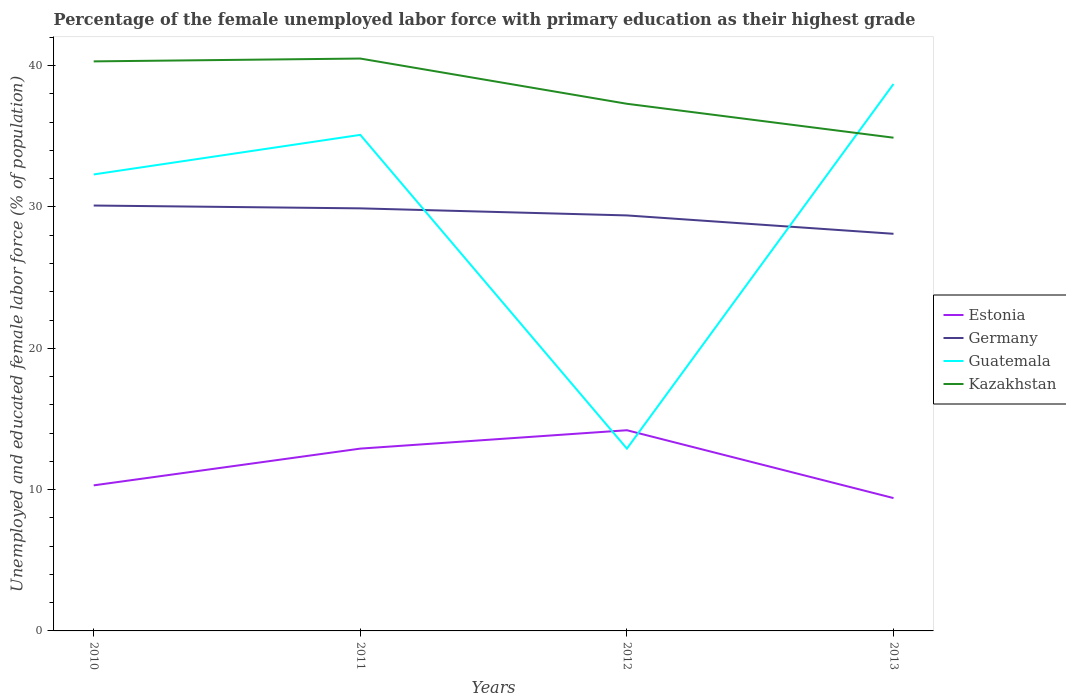How many different coloured lines are there?
Make the answer very short. 4. Is the number of lines equal to the number of legend labels?
Your answer should be compact. Yes. Across all years, what is the maximum percentage of the unemployed female labor force with primary education in Germany?
Provide a short and direct response. 28.1. What is the total percentage of the unemployed female labor force with primary education in Guatemala in the graph?
Your answer should be compact. -3.6. What is the difference between the highest and the second highest percentage of the unemployed female labor force with primary education in Estonia?
Give a very brief answer. 4.8. What is the difference between the highest and the lowest percentage of the unemployed female labor force with primary education in Guatemala?
Ensure brevity in your answer.  3. Is the percentage of the unemployed female labor force with primary education in Kazakhstan strictly greater than the percentage of the unemployed female labor force with primary education in Guatemala over the years?
Provide a succinct answer. No. How many lines are there?
Your response must be concise. 4. How many years are there in the graph?
Give a very brief answer. 4. Are the values on the major ticks of Y-axis written in scientific E-notation?
Keep it short and to the point. No. How many legend labels are there?
Your answer should be very brief. 4. How are the legend labels stacked?
Your answer should be compact. Vertical. What is the title of the graph?
Offer a very short reply. Percentage of the female unemployed labor force with primary education as their highest grade. Does "Belarus" appear as one of the legend labels in the graph?
Give a very brief answer. No. What is the label or title of the X-axis?
Make the answer very short. Years. What is the label or title of the Y-axis?
Your answer should be very brief. Unemployed and educated female labor force (% of population). What is the Unemployed and educated female labor force (% of population) of Estonia in 2010?
Make the answer very short. 10.3. What is the Unemployed and educated female labor force (% of population) in Germany in 2010?
Offer a very short reply. 30.1. What is the Unemployed and educated female labor force (% of population) in Guatemala in 2010?
Keep it short and to the point. 32.3. What is the Unemployed and educated female labor force (% of population) of Kazakhstan in 2010?
Keep it short and to the point. 40.3. What is the Unemployed and educated female labor force (% of population) in Estonia in 2011?
Provide a succinct answer. 12.9. What is the Unemployed and educated female labor force (% of population) in Germany in 2011?
Keep it short and to the point. 29.9. What is the Unemployed and educated female labor force (% of population) in Guatemala in 2011?
Offer a very short reply. 35.1. What is the Unemployed and educated female labor force (% of population) in Kazakhstan in 2011?
Make the answer very short. 40.5. What is the Unemployed and educated female labor force (% of population) in Estonia in 2012?
Make the answer very short. 14.2. What is the Unemployed and educated female labor force (% of population) of Germany in 2012?
Provide a succinct answer. 29.4. What is the Unemployed and educated female labor force (% of population) of Guatemala in 2012?
Provide a short and direct response. 12.9. What is the Unemployed and educated female labor force (% of population) in Kazakhstan in 2012?
Your response must be concise. 37.3. What is the Unemployed and educated female labor force (% of population) in Estonia in 2013?
Make the answer very short. 9.4. What is the Unemployed and educated female labor force (% of population) of Germany in 2013?
Offer a terse response. 28.1. What is the Unemployed and educated female labor force (% of population) of Guatemala in 2013?
Offer a terse response. 38.7. What is the Unemployed and educated female labor force (% of population) of Kazakhstan in 2013?
Provide a short and direct response. 34.9. Across all years, what is the maximum Unemployed and educated female labor force (% of population) of Estonia?
Offer a terse response. 14.2. Across all years, what is the maximum Unemployed and educated female labor force (% of population) in Germany?
Ensure brevity in your answer.  30.1. Across all years, what is the maximum Unemployed and educated female labor force (% of population) in Guatemala?
Your response must be concise. 38.7. Across all years, what is the maximum Unemployed and educated female labor force (% of population) of Kazakhstan?
Keep it short and to the point. 40.5. Across all years, what is the minimum Unemployed and educated female labor force (% of population) of Estonia?
Provide a succinct answer. 9.4. Across all years, what is the minimum Unemployed and educated female labor force (% of population) of Germany?
Offer a very short reply. 28.1. Across all years, what is the minimum Unemployed and educated female labor force (% of population) in Guatemala?
Offer a terse response. 12.9. Across all years, what is the minimum Unemployed and educated female labor force (% of population) in Kazakhstan?
Provide a succinct answer. 34.9. What is the total Unemployed and educated female labor force (% of population) of Estonia in the graph?
Offer a terse response. 46.8. What is the total Unemployed and educated female labor force (% of population) in Germany in the graph?
Your response must be concise. 117.5. What is the total Unemployed and educated female labor force (% of population) of Guatemala in the graph?
Keep it short and to the point. 119. What is the total Unemployed and educated female labor force (% of population) in Kazakhstan in the graph?
Keep it short and to the point. 153. What is the difference between the Unemployed and educated female labor force (% of population) in Estonia in 2010 and that in 2011?
Provide a succinct answer. -2.6. What is the difference between the Unemployed and educated female labor force (% of population) of Germany in 2010 and that in 2011?
Offer a terse response. 0.2. What is the difference between the Unemployed and educated female labor force (% of population) of Guatemala in 2010 and that in 2011?
Your response must be concise. -2.8. What is the difference between the Unemployed and educated female labor force (% of population) of Kazakhstan in 2010 and that in 2012?
Offer a very short reply. 3. What is the difference between the Unemployed and educated female labor force (% of population) of Germany in 2011 and that in 2012?
Provide a short and direct response. 0.5. What is the difference between the Unemployed and educated female labor force (% of population) in Estonia in 2011 and that in 2013?
Your response must be concise. 3.5. What is the difference between the Unemployed and educated female labor force (% of population) in Guatemala in 2011 and that in 2013?
Your answer should be very brief. -3.6. What is the difference between the Unemployed and educated female labor force (% of population) of Kazakhstan in 2011 and that in 2013?
Your response must be concise. 5.6. What is the difference between the Unemployed and educated female labor force (% of population) in Estonia in 2012 and that in 2013?
Keep it short and to the point. 4.8. What is the difference between the Unemployed and educated female labor force (% of population) in Guatemala in 2012 and that in 2013?
Offer a terse response. -25.8. What is the difference between the Unemployed and educated female labor force (% of population) of Estonia in 2010 and the Unemployed and educated female labor force (% of population) of Germany in 2011?
Provide a short and direct response. -19.6. What is the difference between the Unemployed and educated female labor force (% of population) in Estonia in 2010 and the Unemployed and educated female labor force (% of population) in Guatemala in 2011?
Give a very brief answer. -24.8. What is the difference between the Unemployed and educated female labor force (% of population) in Estonia in 2010 and the Unemployed and educated female labor force (% of population) in Kazakhstan in 2011?
Ensure brevity in your answer.  -30.2. What is the difference between the Unemployed and educated female labor force (% of population) in Estonia in 2010 and the Unemployed and educated female labor force (% of population) in Germany in 2012?
Keep it short and to the point. -19.1. What is the difference between the Unemployed and educated female labor force (% of population) in Germany in 2010 and the Unemployed and educated female labor force (% of population) in Guatemala in 2012?
Your response must be concise. 17.2. What is the difference between the Unemployed and educated female labor force (% of population) in Guatemala in 2010 and the Unemployed and educated female labor force (% of population) in Kazakhstan in 2012?
Offer a terse response. -5. What is the difference between the Unemployed and educated female labor force (% of population) of Estonia in 2010 and the Unemployed and educated female labor force (% of population) of Germany in 2013?
Your answer should be very brief. -17.8. What is the difference between the Unemployed and educated female labor force (% of population) in Estonia in 2010 and the Unemployed and educated female labor force (% of population) in Guatemala in 2013?
Provide a succinct answer. -28.4. What is the difference between the Unemployed and educated female labor force (% of population) in Estonia in 2010 and the Unemployed and educated female labor force (% of population) in Kazakhstan in 2013?
Your answer should be compact. -24.6. What is the difference between the Unemployed and educated female labor force (% of population) of Germany in 2010 and the Unemployed and educated female labor force (% of population) of Kazakhstan in 2013?
Offer a terse response. -4.8. What is the difference between the Unemployed and educated female labor force (% of population) in Guatemala in 2010 and the Unemployed and educated female labor force (% of population) in Kazakhstan in 2013?
Your response must be concise. -2.6. What is the difference between the Unemployed and educated female labor force (% of population) in Estonia in 2011 and the Unemployed and educated female labor force (% of population) in Germany in 2012?
Offer a terse response. -16.5. What is the difference between the Unemployed and educated female labor force (% of population) in Estonia in 2011 and the Unemployed and educated female labor force (% of population) in Guatemala in 2012?
Your answer should be compact. 0. What is the difference between the Unemployed and educated female labor force (% of population) in Estonia in 2011 and the Unemployed and educated female labor force (% of population) in Kazakhstan in 2012?
Your answer should be compact. -24.4. What is the difference between the Unemployed and educated female labor force (% of population) in Germany in 2011 and the Unemployed and educated female labor force (% of population) in Guatemala in 2012?
Your answer should be compact. 17. What is the difference between the Unemployed and educated female labor force (% of population) in Guatemala in 2011 and the Unemployed and educated female labor force (% of population) in Kazakhstan in 2012?
Give a very brief answer. -2.2. What is the difference between the Unemployed and educated female labor force (% of population) in Estonia in 2011 and the Unemployed and educated female labor force (% of population) in Germany in 2013?
Ensure brevity in your answer.  -15.2. What is the difference between the Unemployed and educated female labor force (% of population) of Estonia in 2011 and the Unemployed and educated female labor force (% of population) of Guatemala in 2013?
Your answer should be compact. -25.8. What is the difference between the Unemployed and educated female labor force (% of population) in Estonia in 2011 and the Unemployed and educated female labor force (% of population) in Kazakhstan in 2013?
Provide a short and direct response. -22. What is the difference between the Unemployed and educated female labor force (% of population) in Guatemala in 2011 and the Unemployed and educated female labor force (% of population) in Kazakhstan in 2013?
Offer a very short reply. 0.2. What is the difference between the Unemployed and educated female labor force (% of population) in Estonia in 2012 and the Unemployed and educated female labor force (% of population) in Guatemala in 2013?
Ensure brevity in your answer.  -24.5. What is the difference between the Unemployed and educated female labor force (% of population) in Estonia in 2012 and the Unemployed and educated female labor force (% of population) in Kazakhstan in 2013?
Keep it short and to the point. -20.7. What is the difference between the Unemployed and educated female labor force (% of population) in Germany in 2012 and the Unemployed and educated female labor force (% of population) in Kazakhstan in 2013?
Keep it short and to the point. -5.5. What is the difference between the Unemployed and educated female labor force (% of population) in Guatemala in 2012 and the Unemployed and educated female labor force (% of population) in Kazakhstan in 2013?
Your answer should be very brief. -22. What is the average Unemployed and educated female labor force (% of population) in Germany per year?
Provide a succinct answer. 29.38. What is the average Unemployed and educated female labor force (% of population) in Guatemala per year?
Provide a succinct answer. 29.75. What is the average Unemployed and educated female labor force (% of population) in Kazakhstan per year?
Give a very brief answer. 38.25. In the year 2010, what is the difference between the Unemployed and educated female labor force (% of population) in Estonia and Unemployed and educated female labor force (% of population) in Germany?
Offer a terse response. -19.8. In the year 2010, what is the difference between the Unemployed and educated female labor force (% of population) of Estonia and Unemployed and educated female labor force (% of population) of Kazakhstan?
Ensure brevity in your answer.  -30. In the year 2010, what is the difference between the Unemployed and educated female labor force (% of population) in Germany and Unemployed and educated female labor force (% of population) in Guatemala?
Your response must be concise. -2.2. In the year 2011, what is the difference between the Unemployed and educated female labor force (% of population) of Estonia and Unemployed and educated female labor force (% of population) of Guatemala?
Your answer should be compact. -22.2. In the year 2011, what is the difference between the Unemployed and educated female labor force (% of population) of Estonia and Unemployed and educated female labor force (% of population) of Kazakhstan?
Provide a succinct answer. -27.6. In the year 2011, what is the difference between the Unemployed and educated female labor force (% of population) of Germany and Unemployed and educated female labor force (% of population) of Guatemala?
Give a very brief answer. -5.2. In the year 2011, what is the difference between the Unemployed and educated female labor force (% of population) in Germany and Unemployed and educated female labor force (% of population) in Kazakhstan?
Your answer should be very brief. -10.6. In the year 2011, what is the difference between the Unemployed and educated female labor force (% of population) of Guatemala and Unemployed and educated female labor force (% of population) of Kazakhstan?
Provide a succinct answer. -5.4. In the year 2012, what is the difference between the Unemployed and educated female labor force (% of population) in Estonia and Unemployed and educated female labor force (% of population) in Germany?
Provide a short and direct response. -15.2. In the year 2012, what is the difference between the Unemployed and educated female labor force (% of population) of Estonia and Unemployed and educated female labor force (% of population) of Kazakhstan?
Offer a very short reply. -23.1. In the year 2012, what is the difference between the Unemployed and educated female labor force (% of population) in Germany and Unemployed and educated female labor force (% of population) in Guatemala?
Make the answer very short. 16.5. In the year 2012, what is the difference between the Unemployed and educated female labor force (% of population) of Germany and Unemployed and educated female labor force (% of population) of Kazakhstan?
Provide a succinct answer. -7.9. In the year 2012, what is the difference between the Unemployed and educated female labor force (% of population) of Guatemala and Unemployed and educated female labor force (% of population) of Kazakhstan?
Your response must be concise. -24.4. In the year 2013, what is the difference between the Unemployed and educated female labor force (% of population) of Estonia and Unemployed and educated female labor force (% of population) of Germany?
Your answer should be compact. -18.7. In the year 2013, what is the difference between the Unemployed and educated female labor force (% of population) in Estonia and Unemployed and educated female labor force (% of population) in Guatemala?
Offer a very short reply. -29.3. In the year 2013, what is the difference between the Unemployed and educated female labor force (% of population) in Estonia and Unemployed and educated female labor force (% of population) in Kazakhstan?
Offer a very short reply. -25.5. In the year 2013, what is the difference between the Unemployed and educated female labor force (% of population) of Germany and Unemployed and educated female labor force (% of population) of Guatemala?
Provide a short and direct response. -10.6. In the year 2013, what is the difference between the Unemployed and educated female labor force (% of population) in Germany and Unemployed and educated female labor force (% of population) in Kazakhstan?
Ensure brevity in your answer.  -6.8. What is the ratio of the Unemployed and educated female labor force (% of population) of Estonia in 2010 to that in 2011?
Your response must be concise. 0.8. What is the ratio of the Unemployed and educated female labor force (% of population) in Germany in 2010 to that in 2011?
Make the answer very short. 1.01. What is the ratio of the Unemployed and educated female labor force (% of population) of Guatemala in 2010 to that in 2011?
Your answer should be very brief. 0.92. What is the ratio of the Unemployed and educated female labor force (% of population) of Kazakhstan in 2010 to that in 2011?
Your answer should be compact. 1. What is the ratio of the Unemployed and educated female labor force (% of population) in Estonia in 2010 to that in 2012?
Offer a terse response. 0.73. What is the ratio of the Unemployed and educated female labor force (% of population) in Germany in 2010 to that in 2012?
Provide a short and direct response. 1.02. What is the ratio of the Unemployed and educated female labor force (% of population) in Guatemala in 2010 to that in 2012?
Give a very brief answer. 2.5. What is the ratio of the Unemployed and educated female labor force (% of population) in Kazakhstan in 2010 to that in 2012?
Your response must be concise. 1.08. What is the ratio of the Unemployed and educated female labor force (% of population) in Estonia in 2010 to that in 2013?
Offer a very short reply. 1.1. What is the ratio of the Unemployed and educated female labor force (% of population) in Germany in 2010 to that in 2013?
Keep it short and to the point. 1.07. What is the ratio of the Unemployed and educated female labor force (% of population) of Guatemala in 2010 to that in 2013?
Your answer should be compact. 0.83. What is the ratio of the Unemployed and educated female labor force (% of population) in Kazakhstan in 2010 to that in 2013?
Ensure brevity in your answer.  1.15. What is the ratio of the Unemployed and educated female labor force (% of population) of Estonia in 2011 to that in 2012?
Ensure brevity in your answer.  0.91. What is the ratio of the Unemployed and educated female labor force (% of population) in Germany in 2011 to that in 2012?
Offer a very short reply. 1.02. What is the ratio of the Unemployed and educated female labor force (% of population) of Guatemala in 2011 to that in 2012?
Offer a very short reply. 2.72. What is the ratio of the Unemployed and educated female labor force (% of population) of Kazakhstan in 2011 to that in 2012?
Ensure brevity in your answer.  1.09. What is the ratio of the Unemployed and educated female labor force (% of population) of Estonia in 2011 to that in 2013?
Make the answer very short. 1.37. What is the ratio of the Unemployed and educated female labor force (% of population) in Germany in 2011 to that in 2013?
Give a very brief answer. 1.06. What is the ratio of the Unemployed and educated female labor force (% of population) of Guatemala in 2011 to that in 2013?
Your answer should be very brief. 0.91. What is the ratio of the Unemployed and educated female labor force (% of population) in Kazakhstan in 2011 to that in 2013?
Provide a short and direct response. 1.16. What is the ratio of the Unemployed and educated female labor force (% of population) in Estonia in 2012 to that in 2013?
Ensure brevity in your answer.  1.51. What is the ratio of the Unemployed and educated female labor force (% of population) in Germany in 2012 to that in 2013?
Offer a very short reply. 1.05. What is the ratio of the Unemployed and educated female labor force (% of population) in Kazakhstan in 2012 to that in 2013?
Your response must be concise. 1.07. What is the difference between the highest and the second highest Unemployed and educated female labor force (% of population) of Germany?
Provide a short and direct response. 0.2. What is the difference between the highest and the second highest Unemployed and educated female labor force (% of population) of Guatemala?
Your answer should be very brief. 3.6. What is the difference between the highest and the lowest Unemployed and educated female labor force (% of population) in Estonia?
Your response must be concise. 4.8. What is the difference between the highest and the lowest Unemployed and educated female labor force (% of population) in Guatemala?
Ensure brevity in your answer.  25.8. What is the difference between the highest and the lowest Unemployed and educated female labor force (% of population) of Kazakhstan?
Make the answer very short. 5.6. 